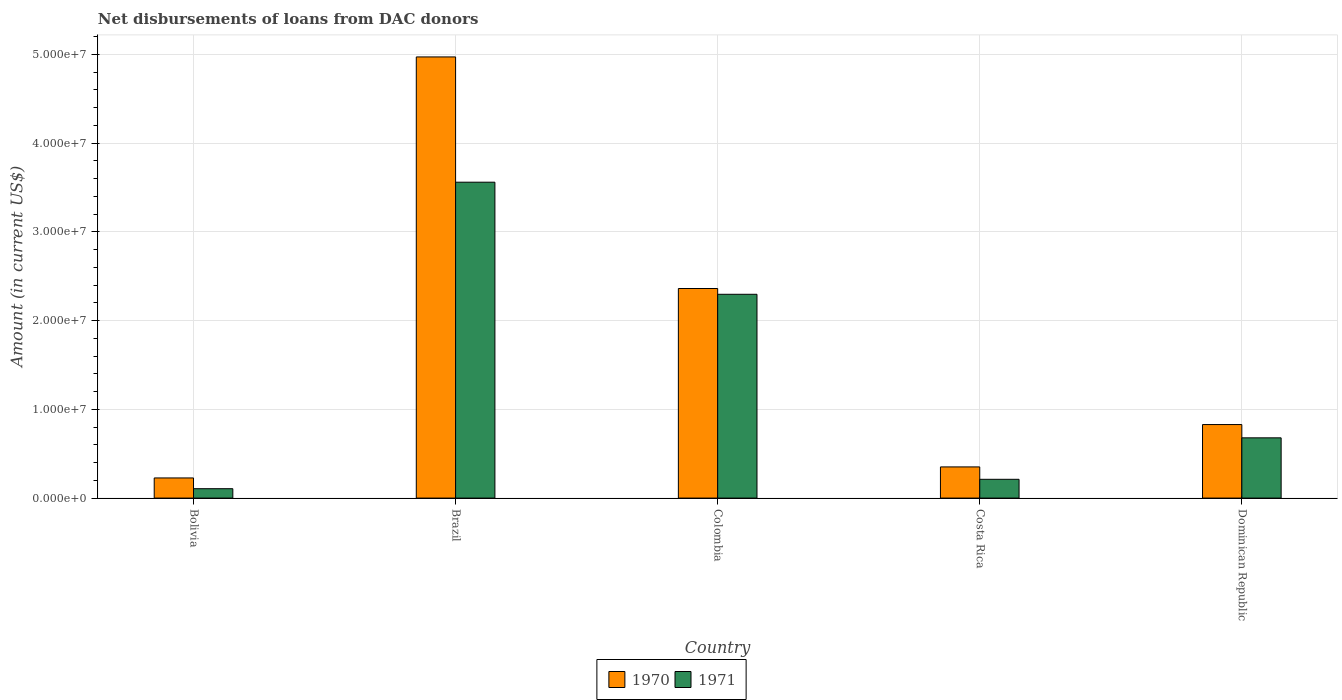How many different coloured bars are there?
Your response must be concise. 2. How many bars are there on the 4th tick from the left?
Provide a succinct answer. 2. What is the amount of loans disbursed in 1971 in Dominican Republic?
Your answer should be compact. 6.79e+06. Across all countries, what is the maximum amount of loans disbursed in 1971?
Your answer should be very brief. 3.56e+07. Across all countries, what is the minimum amount of loans disbursed in 1970?
Your response must be concise. 2.27e+06. In which country was the amount of loans disbursed in 1971 minimum?
Make the answer very short. Bolivia. What is the total amount of loans disbursed in 1970 in the graph?
Offer a terse response. 8.74e+07. What is the difference between the amount of loans disbursed in 1971 in Bolivia and that in Dominican Republic?
Ensure brevity in your answer.  -5.73e+06. What is the difference between the amount of loans disbursed in 1970 in Dominican Republic and the amount of loans disbursed in 1971 in Costa Rica?
Your answer should be very brief. 6.17e+06. What is the average amount of loans disbursed in 1971 per country?
Keep it short and to the point. 1.37e+07. What is the difference between the amount of loans disbursed of/in 1971 and amount of loans disbursed of/in 1970 in Brazil?
Make the answer very short. -1.41e+07. What is the ratio of the amount of loans disbursed in 1970 in Bolivia to that in Dominican Republic?
Keep it short and to the point. 0.27. What is the difference between the highest and the second highest amount of loans disbursed in 1970?
Keep it short and to the point. 2.61e+07. What is the difference between the highest and the lowest amount of loans disbursed in 1971?
Give a very brief answer. 3.45e+07. Is the sum of the amount of loans disbursed in 1970 in Brazil and Colombia greater than the maximum amount of loans disbursed in 1971 across all countries?
Make the answer very short. Yes. What does the 1st bar from the left in Bolivia represents?
Offer a very short reply. 1970. How many bars are there?
Give a very brief answer. 10. Are all the bars in the graph horizontal?
Provide a succinct answer. No. How many countries are there in the graph?
Provide a succinct answer. 5. What is the difference between two consecutive major ticks on the Y-axis?
Keep it short and to the point. 1.00e+07. Are the values on the major ticks of Y-axis written in scientific E-notation?
Ensure brevity in your answer.  Yes. How are the legend labels stacked?
Ensure brevity in your answer.  Horizontal. What is the title of the graph?
Your answer should be compact. Net disbursements of loans from DAC donors. What is the Amount (in current US$) in 1970 in Bolivia?
Your response must be concise. 2.27e+06. What is the Amount (in current US$) of 1971 in Bolivia?
Keep it short and to the point. 1.06e+06. What is the Amount (in current US$) in 1970 in Brazil?
Offer a very short reply. 4.97e+07. What is the Amount (in current US$) of 1971 in Brazil?
Offer a terse response. 3.56e+07. What is the Amount (in current US$) in 1970 in Colombia?
Provide a succinct answer. 2.36e+07. What is the Amount (in current US$) in 1971 in Colombia?
Keep it short and to the point. 2.30e+07. What is the Amount (in current US$) of 1970 in Costa Rica?
Provide a succinct answer. 3.51e+06. What is the Amount (in current US$) in 1971 in Costa Rica?
Offer a terse response. 2.12e+06. What is the Amount (in current US$) of 1970 in Dominican Republic?
Give a very brief answer. 8.29e+06. What is the Amount (in current US$) of 1971 in Dominican Republic?
Provide a short and direct response. 6.79e+06. Across all countries, what is the maximum Amount (in current US$) in 1970?
Ensure brevity in your answer.  4.97e+07. Across all countries, what is the maximum Amount (in current US$) of 1971?
Make the answer very short. 3.56e+07. Across all countries, what is the minimum Amount (in current US$) of 1970?
Give a very brief answer. 2.27e+06. Across all countries, what is the minimum Amount (in current US$) in 1971?
Provide a short and direct response. 1.06e+06. What is the total Amount (in current US$) in 1970 in the graph?
Give a very brief answer. 8.74e+07. What is the total Amount (in current US$) in 1971 in the graph?
Offer a very short reply. 6.85e+07. What is the difference between the Amount (in current US$) in 1970 in Bolivia and that in Brazil?
Provide a succinct answer. -4.74e+07. What is the difference between the Amount (in current US$) in 1971 in Bolivia and that in Brazil?
Offer a terse response. -3.45e+07. What is the difference between the Amount (in current US$) of 1970 in Bolivia and that in Colombia?
Offer a terse response. -2.13e+07. What is the difference between the Amount (in current US$) of 1971 in Bolivia and that in Colombia?
Keep it short and to the point. -2.19e+07. What is the difference between the Amount (in current US$) of 1970 in Bolivia and that in Costa Rica?
Your answer should be very brief. -1.24e+06. What is the difference between the Amount (in current US$) in 1971 in Bolivia and that in Costa Rica?
Make the answer very short. -1.06e+06. What is the difference between the Amount (in current US$) in 1970 in Bolivia and that in Dominican Republic?
Offer a very short reply. -6.02e+06. What is the difference between the Amount (in current US$) in 1971 in Bolivia and that in Dominican Republic?
Your answer should be very brief. -5.73e+06. What is the difference between the Amount (in current US$) of 1970 in Brazil and that in Colombia?
Provide a short and direct response. 2.61e+07. What is the difference between the Amount (in current US$) of 1971 in Brazil and that in Colombia?
Your response must be concise. 1.26e+07. What is the difference between the Amount (in current US$) of 1970 in Brazil and that in Costa Rica?
Offer a very short reply. 4.62e+07. What is the difference between the Amount (in current US$) in 1971 in Brazil and that in Costa Rica?
Your response must be concise. 3.35e+07. What is the difference between the Amount (in current US$) of 1970 in Brazil and that in Dominican Republic?
Give a very brief answer. 4.14e+07. What is the difference between the Amount (in current US$) in 1971 in Brazil and that in Dominican Republic?
Provide a succinct answer. 2.88e+07. What is the difference between the Amount (in current US$) in 1970 in Colombia and that in Costa Rica?
Offer a terse response. 2.01e+07. What is the difference between the Amount (in current US$) of 1971 in Colombia and that in Costa Rica?
Offer a terse response. 2.08e+07. What is the difference between the Amount (in current US$) in 1970 in Colombia and that in Dominican Republic?
Offer a terse response. 1.53e+07. What is the difference between the Amount (in current US$) in 1971 in Colombia and that in Dominican Republic?
Offer a terse response. 1.62e+07. What is the difference between the Amount (in current US$) of 1970 in Costa Rica and that in Dominican Republic?
Make the answer very short. -4.77e+06. What is the difference between the Amount (in current US$) in 1971 in Costa Rica and that in Dominican Republic?
Ensure brevity in your answer.  -4.67e+06. What is the difference between the Amount (in current US$) in 1970 in Bolivia and the Amount (in current US$) in 1971 in Brazil?
Offer a terse response. -3.33e+07. What is the difference between the Amount (in current US$) in 1970 in Bolivia and the Amount (in current US$) in 1971 in Colombia?
Provide a succinct answer. -2.07e+07. What is the difference between the Amount (in current US$) in 1970 in Bolivia and the Amount (in current US$) in 1971 in Costa Rica?
Provide a succinct answer. 1.54e+05. What is the difference between the Amount (in current US$) in 1970 in Bolivia and the Amount (in current US$) in 1971 in Dominican Republic?
Ensure brevity in your answer.  -4.52e+06. What is the difference between the Amount (in current US$) of 1970 in Brazil and the Amount (in current US$) of 1971 in Colombia?
Your answer should be very brief. 2.67e+07. What is the difference between the Amount (in current US$) in 1970 in Brazil and the Amount (in current US$) in 1971 in Costa Rica?
Your response must be concise. 4.76e+07. What is the difference between the Amount (in current US$) in 1970 in Brazil and the Amount (in current US$) in 1971 in Dominican Republic?
Provide a short and direct response. 4.29e+07. What is the difference between the Amount (in current US$) of 1970 in Colombia and the Amount (in current US$) of 1971 in Costa Rica?
Offer a very short reply. 2.15e+07. What is the difference between the Amount (in current US$) in 1970 in Colombia and the Amount (in current US$) in 1971 in Dominican Republic?
Make the answer very short. 1.68e+07. What is the difference between the Amount (in current US$) of 1970 in Costa Rica and the Amount (in current US$) of 1971 in Dominican Republic?
Your answer should be very brief. -3.28e+06. What is the average Amount (in current US$) of 1970 per country?
Provide a short and direct response. 1.75e+07. What is the average Amount (in current US$) in 1971 per country?
Ensure brevity in your answer.  1.37e+07. What is the difference between the Amount (in current US$) in 1970 and Amount (in current US$) in 1971 in Bolivia?
Your response must be concise. 1.21e+06. What is the difference between the Amount (in current US$) in 1970 and Amount (in current US$) in 1971 in Brazil?
Offer a very short reply. 1.41e+07. What is the difference between the Amount (in current US$) of 1970 and Amount (in current US$) of 1971 in Colombia?
Give a very brief answer. 6.52e+05. What is the difference between the Amount (in current US$) of 1970 and Amount (in current US$) of 1971 in Costa Rica?
Your answer should be compact. 1.40e+06. What is the difference between the Amount (in current US$) in 1970 and Amount (in current US$) in 1971 in Dominican Republic?
Provide a short and direct response. 1.50e+06. What is the ratio of the Amount (in current US$) in 1970 in Bolivia to that in Brazil?
Your response must be concise. 0.05. What is the ratio of the Amount (in current US$) of 1971 in Bolivia to that in Brazil?
Make the answer very short. 0.03. What is the ratio of the Amount (in current US$) of 1970 in Bolivia to that in Colombia?
Give a very brief answer. 0.1. What is the ratio of the Amount (in current US$) in 1971 in Bolivia to that in Colombia?
Your answer should be very brief. 0.05. What is the ratio of the Amount (in current US$) of 1970 in Bolivia to that in Costa Rica?
Provide a succinct answer. 0.65. What is the ratio of the Amount (in current US$) of 1970 in Bolivia to that in Dominican Republic?
Your answer should be compact. 0.27. What is the ratio of the Amount (in current US$) of 1971 in Bolivia to that in Dominican Republic?
Your answer should be compact. 0.16. What is the ratio of the Amount (in current US$) in 1970 in Brazil to that in Colombia?
Your answer should be compact. 2.1. What is the ratio of the Amount (in current US$) of 1971 in Brazil to that in Colombia?
Offer a very short reply. 1.55. What is the ratio of the Amount (in current US$) of 1970 in Brazil to that in Costa Rica?
Offer a terse response. 14.15. What is the ratio of the Amount (in current US$) in 1971 in Brazil to that in Costa Rica?
Keep it short and to the point. 16.82. What is the ratio of the Amount (in current US$) in 1970 in Brazil to that in Dominican Republic?
Your answer should be very brief. 6. What is the ratio of the Amount (in current US$) of 1971 in Brazil to that in Dominican Republic?
Your answer should be very brief. 5.24. What is the ratio of the Amount (in current US$) in 1970 in Colombia to that in Costa Rica?
Provide a short and direct response. 6.72. What is the ratio of the Amount (in current US$) of 1971 in Colombia to that in Costa Rica?
Your answer should be compact. 10.85. What is the ratio of the Amount (in current US$) in 1970 in Colombia to that in Dominican Republic?
Your answer should be compact. 2.85. What is the ratio of the Amount (in current US$) in 1971 in Colombia to that in Dominican Republic?
Your response must be concise. 3.38. What is the ratio of the Amount (in current US$) of 1970 in Costa Rica to that in Dominican Republic?
Give a very brief answer. 0.42. What is the ratio of the Amount (in current US$) of 1971 in Costa Rica to that in Dominican Republic?
Ensure brevity in your answer.  0.31. What is the difference between the highest and the second highest Amount (in current US$) of 1970?
Provide a short and direct response. 2.61e+07. What is the difference between the highest and the second highest Amount (in current US$) of 1971?
Keep it short and to the point. 1.26e+07. What is the difference between the highest and the lowest Amount (in current US$) in 1970?
Keep it short and to the point. 4.74e+07. What is the difference between the highest and the lowest Amount (in current US$) of 1971?
Offer a terse response. 3.45e+07. 